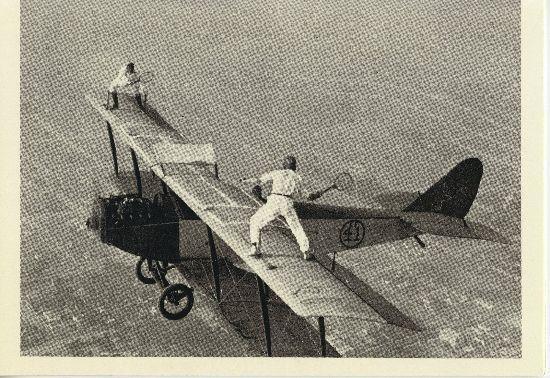How many people are in the photo?
Give a very brief answer. 1. 